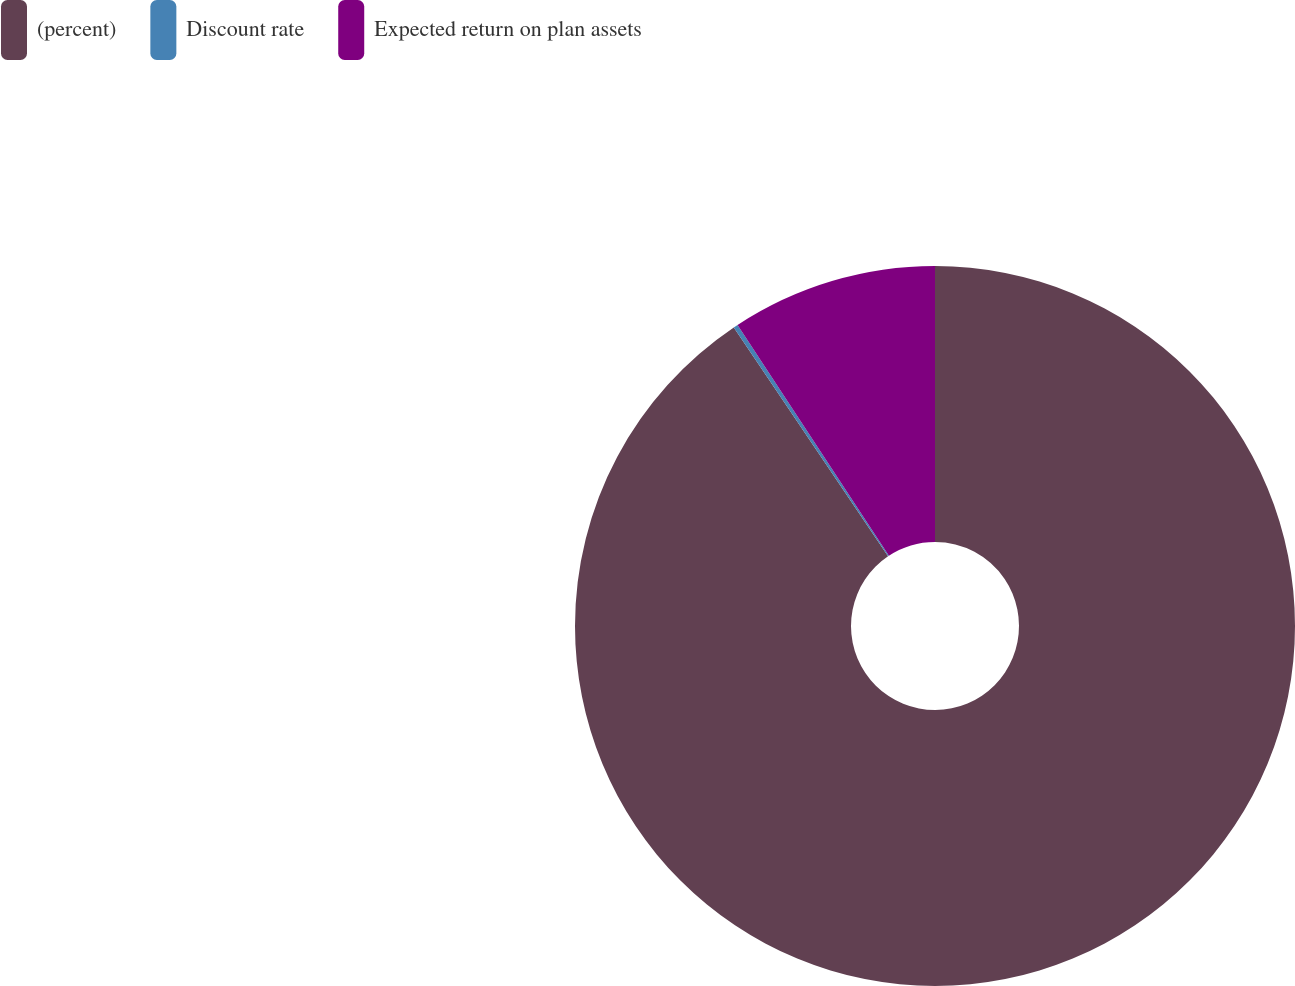<chart> <loc_0><loc_0><loc_500><loc_500><pie_chart><fcel>(percent)<fcel>Discount rate<fcel>Expected return on plan assets<nl><fcel>90.56%<fcel>0.2%<fcel>9.24%<nl></chart> 